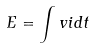<formula> <loc_0><loc_0><loc_500><loc_500>E = \int v i d t</formula> 